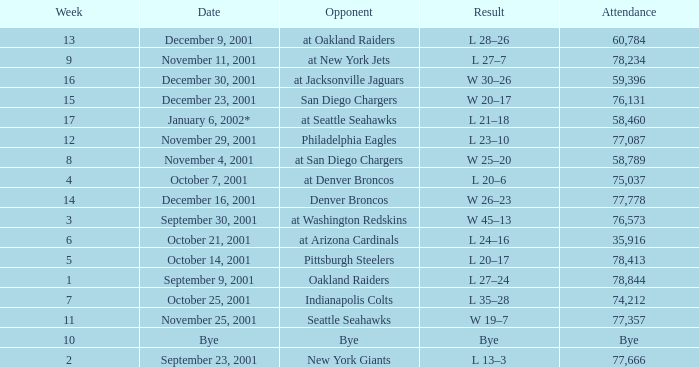How many attended the game on December 16, 2001? 77778.0. 